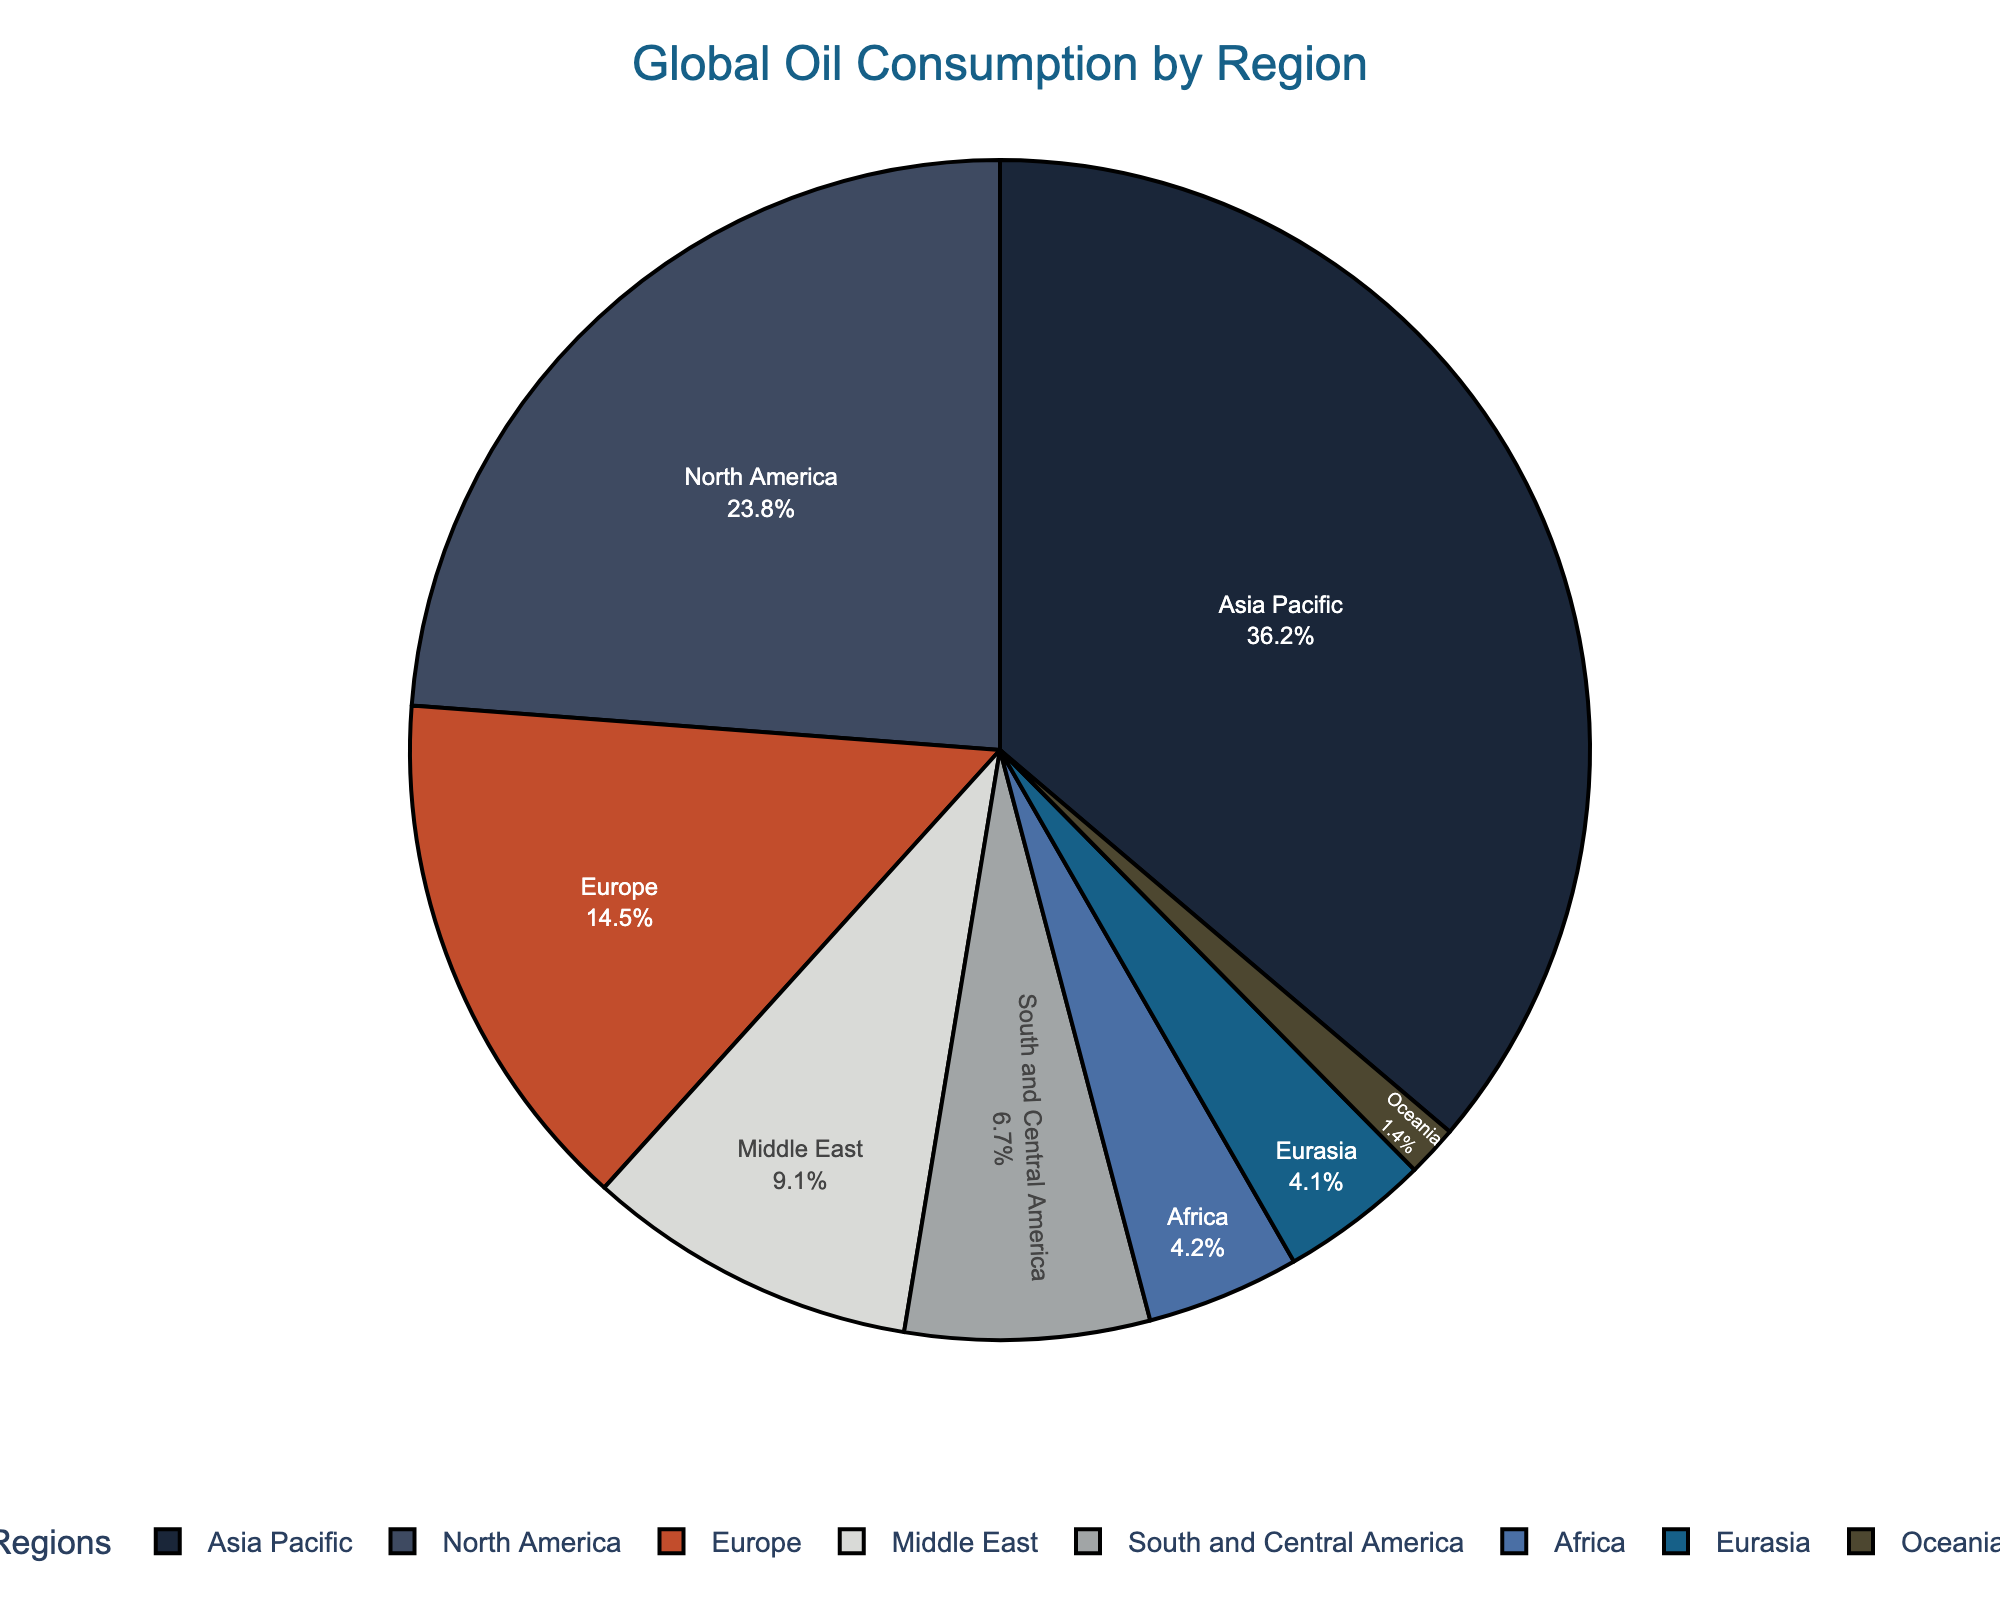Which region consumes the most oil? To determine the region with the highest oil consumption, look for the largest slice in the pie chart, which represents the "Asia Pacific" region.
Answer: Asia Pacific Which two regions have the closest oil consumption amounts? Find the two regions with pie slices of similar size. "Eurasia" and "Africa" have very close consumption figures.
Answer: Eurasia and Africa What's the sum of oil consumption for Europe and the Middle East? Add the oil consumption values for Europe (14.5 MBD) and the Middle East (9.1 MBD). This sum is 14.5 + 9.1 = 23.6 MBD.
Answer: 23.6 MBD Is North America's oil consumption greater than that of Europe and Africa combined? Calculate the combined oil consumption of Europe (14.5 MBD) and Africa (4.2 MBD). This value is 14.5 + 4.2 = 18.7 MBD. Compare this with North America's consumption of 23.8 MBD. North America's consumption is greater.
Answer: Yes What percentage of the total oil consumption does South and Central America contribute? Find the slice labeled "South and Central America" and look at the percentage value inside this slice.
Answer: 6.5% If Middle East's oil consumption were to double, where would it stand relative to North America and Asia Pacific? Doubling Middle East's consumption (9.1 MBD) results in 18.2 MBD. This is less than North America's 23.8 MBD and much less than Asia Pacific's 36.2 MBD.
Answer: Less than North America and Asia Pacific What is the ratio of oil consumption between North America and Oceania? Calculate the ratio by dividing North America's consumption (23.8 MBD) by Oceania's consumption (1.4 MBD). This ratio is 23.8 / 1.4 = 17.
Answer: 17 Comparatively, does the Middle East or Europe consume a larger portion of oil? Observe the size of the pie slices for the Middle East and Europe. Europe's slice is larger, indicating it consumes more.
Answer: Europe If Asia Pacific decreased its consumption by 5 million barrels per day, how would its new consumption compare to North America's? Subtract 5 from Asia Pacific’s consumption (36.2 - 5 = 31.2 MBD) and compare to North America's 23.8 MBD. Asia Pacific would still consume more.
Answer: Asia Pacific would still consume more Combine the oil consumptions of Africa, Eurasia, and Oceania. Would the sum be less than Europe’s consumption? Add the oil consumption values for Africa (4.2 MBD), Eurasia (4.1 MBD), and Oceania (1.4 MBD): 4.2 + 4.1 + 1.4 = 9.7 MBD. Compare this with Europe’s consumption of 14.5 MBD. The sum is less.
Answer: Yes 